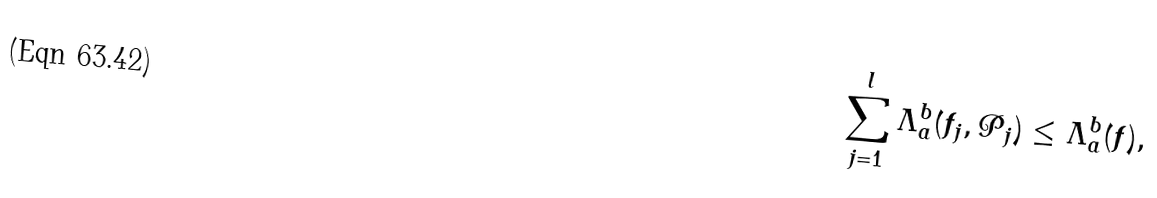<formula> <loc_0><loc_0><loc_500><loc_500>\sum _ { j = 1 } ^ { l } \Lambda _ { a } ^ { b } ( f _ { j } , \mathcal { P } _ { j } ) \leq \Lambda _ { a } ^ { b } ( f ) ,</formula> 